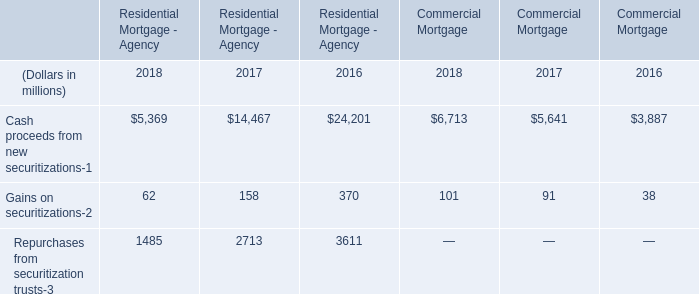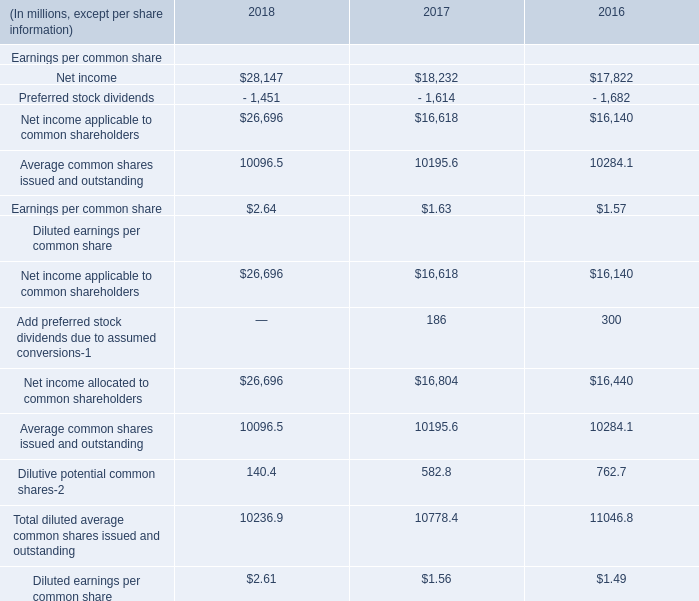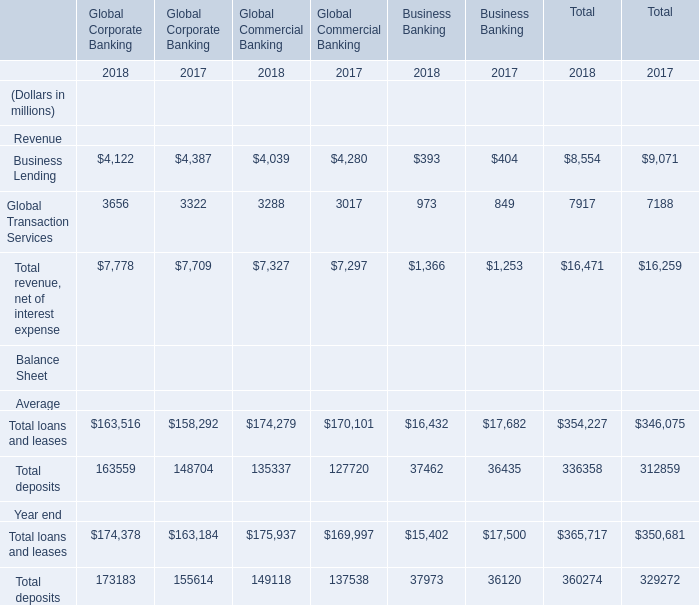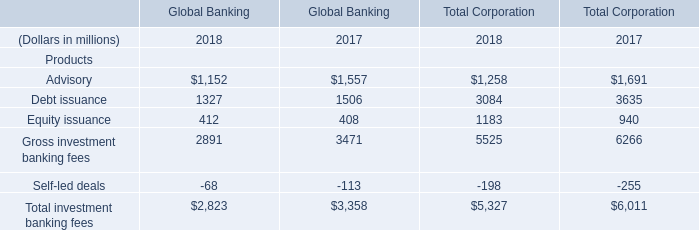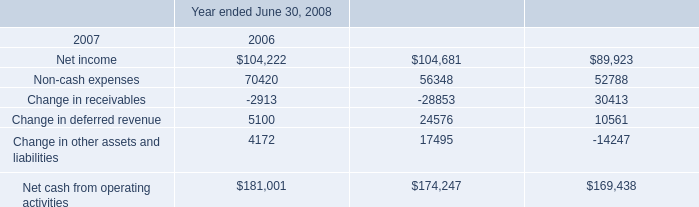What's the current growth rate of Equity issuance of Global Banking? 
Computations: ((412 - 408) / 408)
Answer: 0.0098. 